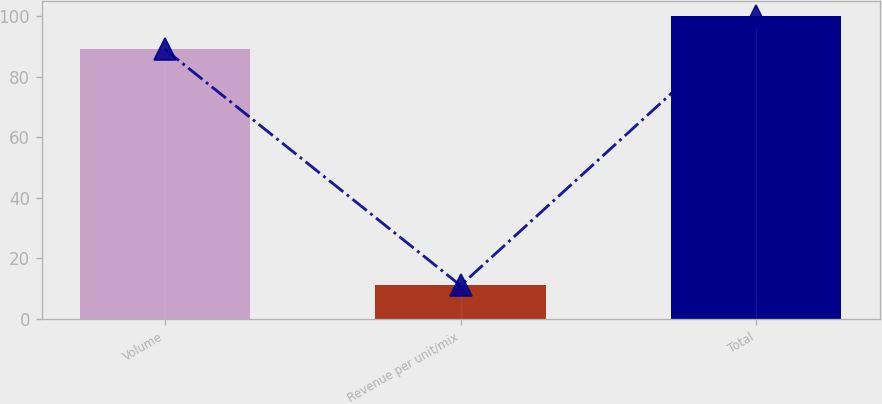Convert chart. <chart><loc_0><loc_0><loc_500><loc_500><bar_chart><fcel>Volume<fcel>Revenue per unit/mix<fcel>Total<nl><fcel>89<fcel>11<fcel>100<nl></chart> 